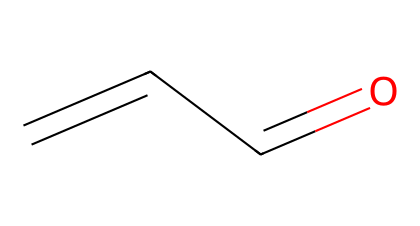How many carbon atoms are in acrolein? The SMILES representation shows 'C=CC', indicating three carbon atoms in total.
Answer: three What type of functional group does acrolein contain? The structure shows a carbonyl group (C=O) at the end of the carbon chain, which characterizes aldehydes.
Answer: aldehyde What is the degree of unsaturation in acrolein? The presence of a double bond (C=C) and a carbonyl group contributes to two degrees of unsaturation (one from C=C and one from C=O).
Answer: two Which atom in acrolein is the carbonyl carbon? In the structure, the carbon that is directly attached to the oxygen atom (C=O) is the carbonyl carbon.
Answer: first carbon What can be inferred about the reactivity of acrolein from its structure? The carbonyl group increases the reactivity of acrolein, as aldehydes are generally more reactive than ketones and alcohols due to the presence of the double bond and an electron-deficient carbon.
Answer: high reactivity Is acrolein a saturated or unsaturated aldehyde? The presence of a double bond (C=C) in its structure indicates that acrolein is unsaturated.
Answer: unsaturated 